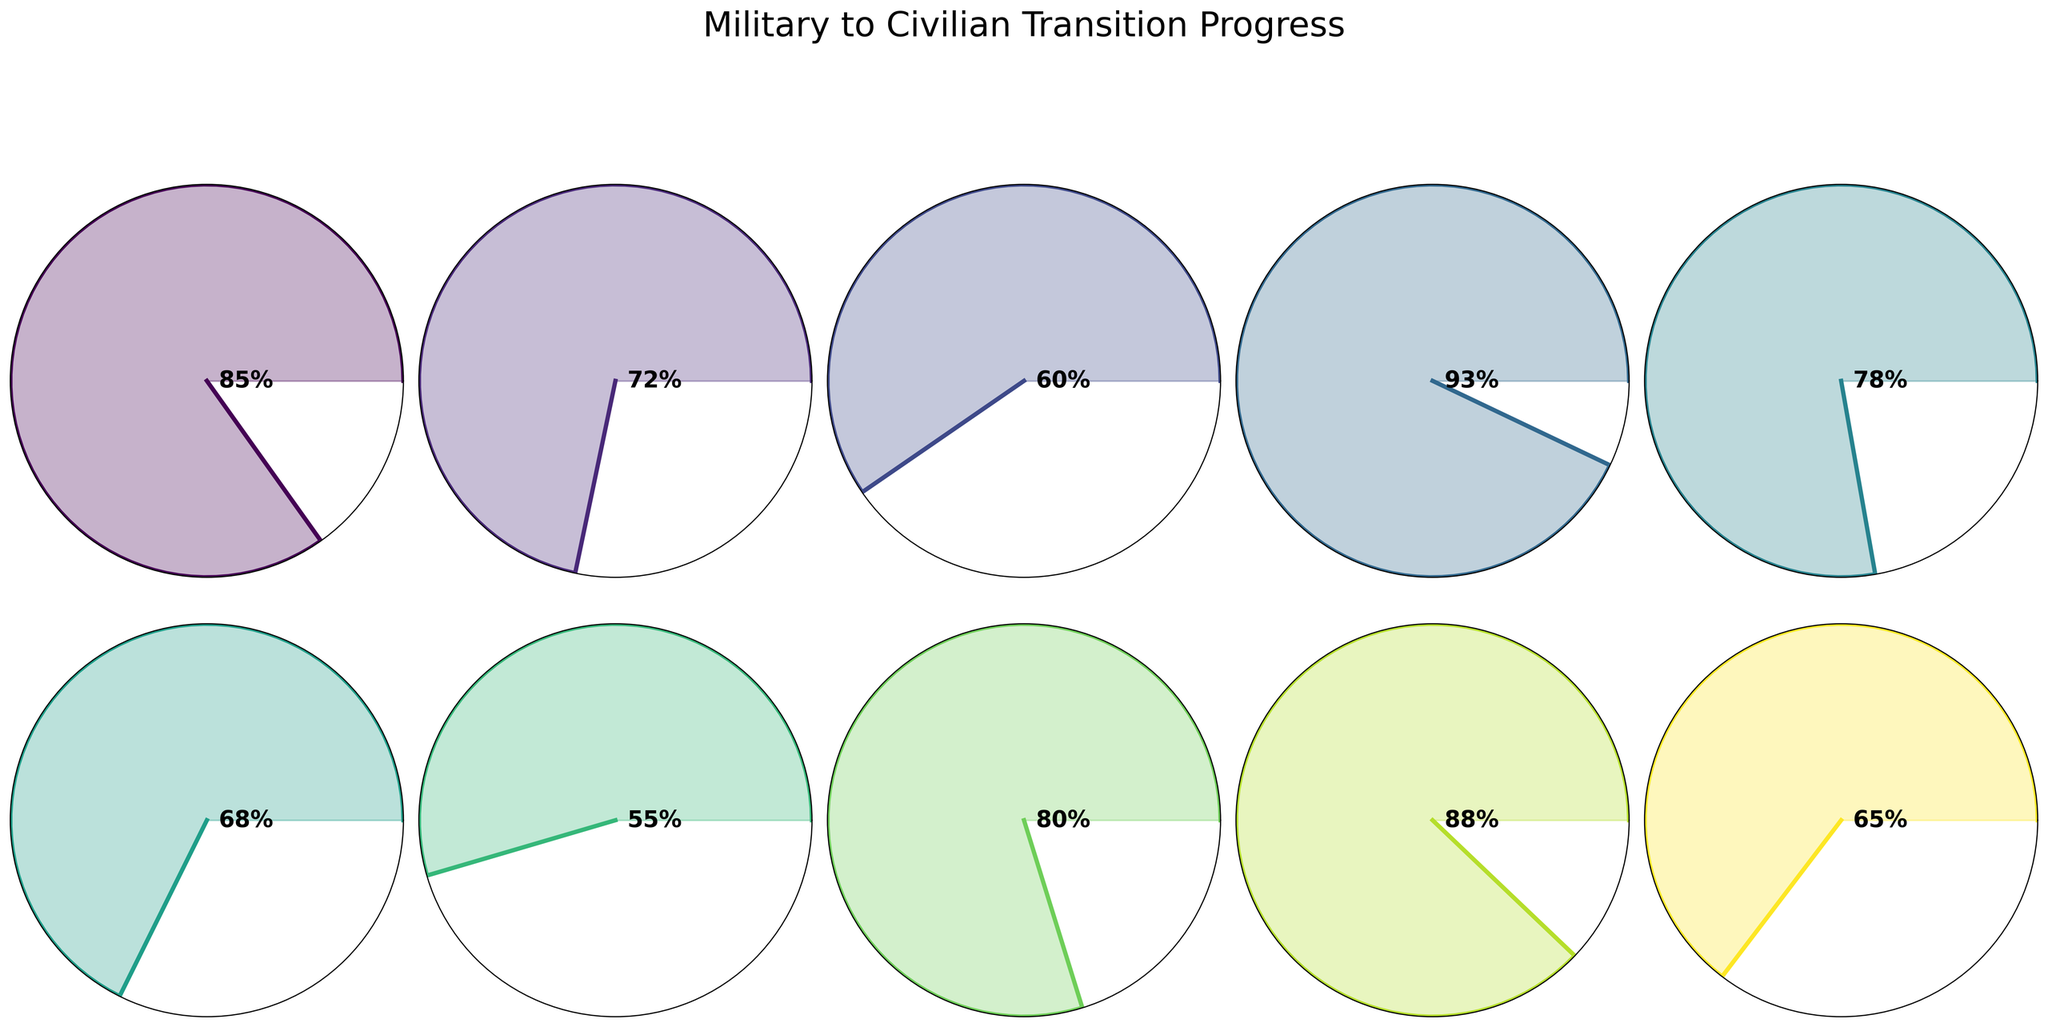What's the title of the figure? The title is often prominently displayed at the top of a figure. In this case, it is "Military to Civilian Transition Progress" as specified in the code.
Answer: Military to Civilian Transition Progress How many milestones are displayed in the figure? By counting the number of gauge charts present, you can determine the number of milestones displayed. The figure shows 10 milestones.
Answer: 10 Which milestone has the highest completion percentage? By looking at the text inside each gauge showing the percentage values, the milestone "Skill Translation Workshop" stands out with a 93% completion rate.
Answer: Skill Translation Workshop Which milestone has the lowest completion percentage? By evaluating all the gauge charts, the milestone with the lowest percentage is "Civilian Certifications Obtained," showing 55%.
Answer: Civilian Certifications Obtained What's the difference in completion percentage between "Basic Civilian Resume Creation" and "Civilian Job Applications Submitted"? "Basic Civilian Resume Creation" has 85%, and "Civilian Job Applications Submitted" has 65%. The difference is 85% - 65% = 20%.
Answer: 20% What's the average completion percentage across all milestones? Add up all the completion percentages and divide by the number of milestones: (85 + 72 + 60 + 93 + 78 + 68 + 55 + 80 + 88 + 65) / 10 = 74.4%.
Answer: 74.4% Which milestones have a completion percentage greater than 80%? Evaluate each gauge and note those above 80%: "Basic Civilian Resume Creation" (85%), "Skill Translation Workshop" (93%), "Mentorship Program Participation" (80%), and "Career Counseling Sessions" (88%).
Answer: Basic Civilian Resume Creation, Skill Translation Workshop, Mentorship Program Participation, Career Counseling Sessions What is the combined completion percentage of "Interview Preparation" and "Networking Events Attended"? "Interview Preparation" stands at 68%, and "Networking Events Attended" at 60%. Their combined percentage is 68% + 60% = 128%.
Answer: 128% Which milestone shows nearly equal progress in percentage compared to "Financial Planning Sessions"? Compare other milestones to "Financial Planning Sessions" at 78%. "Mentorship Program Participation" at 80% is the closest in value.
Answer: Mentorship Program Participation Arrange the milestones in ascending order of completion percentage. List the milestone percentages in order: "Civilian Certifications Obtained" (55%), "Networking Events Attended" (60%), "Civilian Job Applications Submitted" (65%), "Interview Preparation" (68%), "Job Market Research" (72%), "Financial Planning Sessions" (78%), "Mentorship Program Participation" (80%), "Basic Civilian Resume Creation" (85%), "Career Counseling Sessions" (88%), "Skill Translation Workshop" (93%).
Answer: Civilian Certifications Obtained, Networking Events Attended, Civilian Job Applications Submitted, Interview Preparation, Job Market Research, Financial Planning Sessions, Mentorship Program Participation, Basic Civilian Resume Creation, Career Counseling Sessions, Skill Translation Workshop 